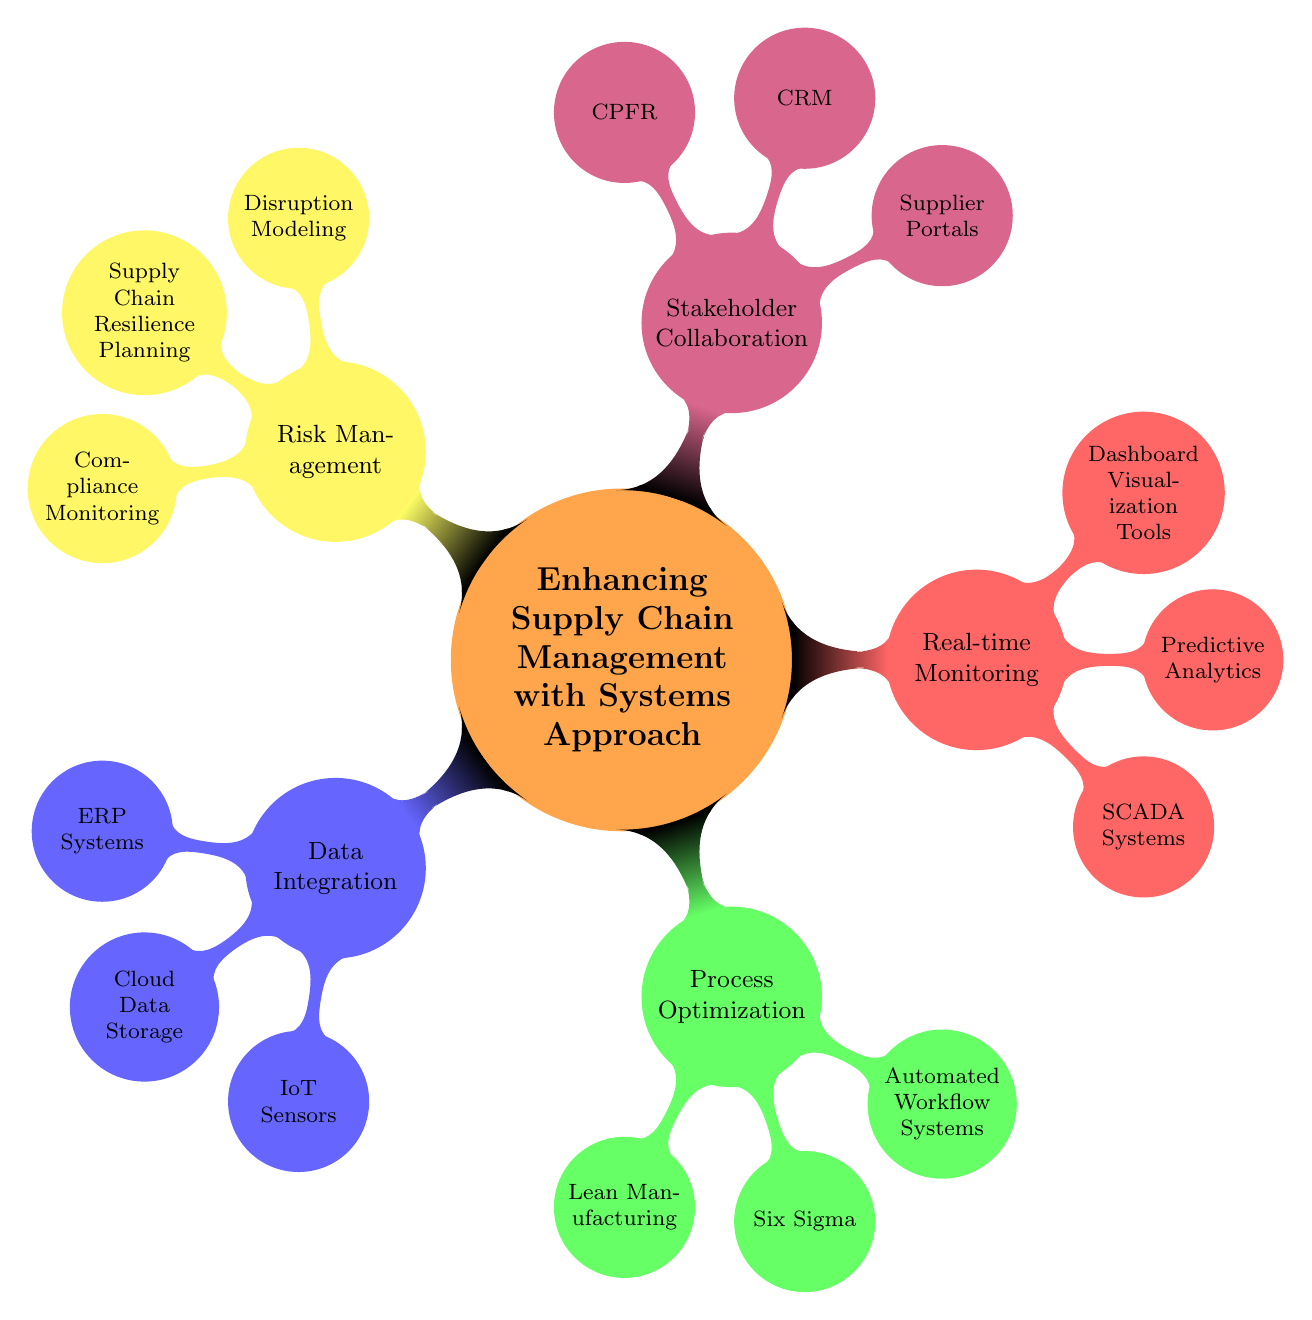What is the main topic of the diagram? The main topic is clearly labeled at the center of the diagram, stating "Enhancing Supply Chain Management with Systems Approach."
Answer: Enhancing Supply Chain Management with Systems Approach How many main nodes are there in the diagram? Observing the diagram, there are five main nodes branching out from the central topic. They are Data Integration, Process Optimization, Real-time Monitoring, Stakeholder Collaboration, and Risk Management.
Answer: 5 What color is the node for Real-time Monitoring? The node for Real-time Monitoring is colored red, as visible in the diagram.
Answer: Red List one subnode under Process Optimization. Looking at the Process Optimization node, it has three subnodes. One of the subnodes is Lean Manufacturing.
Answer: Lean Manufacturing Which node has the subnode 'Supplier Portals'? By checking the diagram, the Stakeholder Collaboration node contains the subnode 'Supplier Portals.'
Answer: Stakeholder Collaboration Which two nodes are directly related to 'Data Integration'? The nodes directly related to 'Data Integration' are ERP Systems, Cloud Data Storage, and IoT Sensors, but the question asks for two; thus, one possible answer would be ERP Systems and Cloud Data Storage.
Answer: ERP Systems, Cloud Data Storage What methodology is represented under Risk Management? The Risk Management node lists different methodologies, one of which is 'Supply Chain Resilience Planning.'
Answer: Supply Chain Resilience Planning Which approach is represented in using 'Automated Workflow Systems'? The presence of 'Automated Workflow Systems' indicates a focus on efficiency within the Process Optimization node.
Answer: Process Optimization What is the relationship between Real-time Monitoring and Predictive Analytics? Predictive Analytics is a subnode directly under the Real-time Monitoring node, indicating that it is a component of achieving real-time monitoring in supply chain management.
Answer: Predictive Analytics is a component of Real-time Monitoring How many subnodes does the Risk Management node have? The Risk Management node includes three subnodes that detail areas of focus within this category.
Answer: 3 